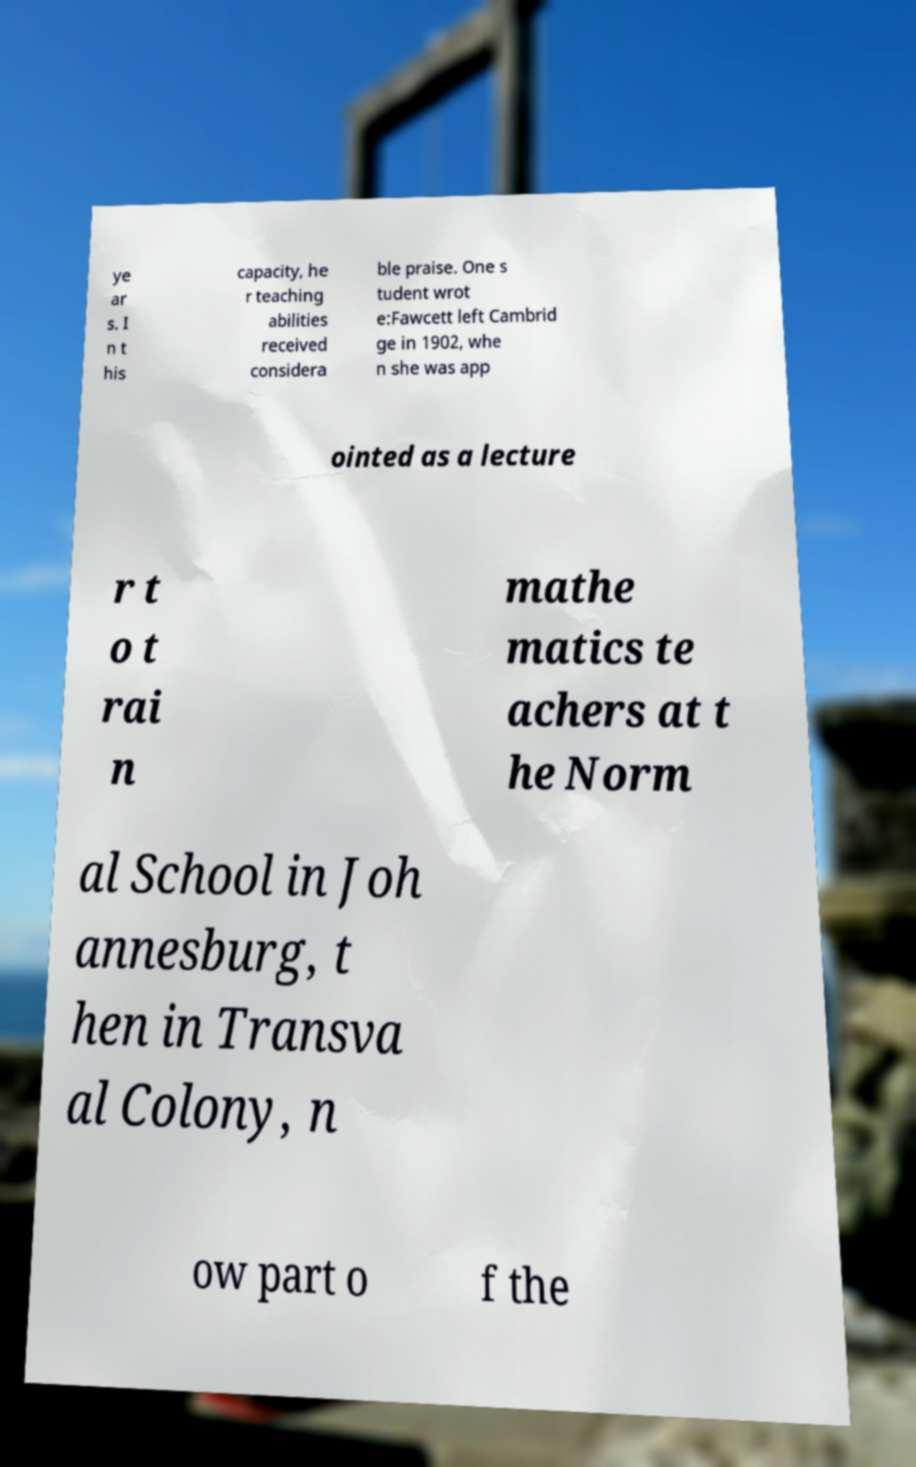For documentation purposes, I need the text within this image transcribed. Could you provide that? ye ar s. I n t his capacity, he r teaching abilities received considera ble praise. One s tudent wrot e:Fawcett left Cambrid ge in 1902, whe n she was app ointed as a lecture r t o t rai n mathe matics te achers at t he Norm al School in Joh annesburg, t hen in Transva al Colony, n ow part o f the 